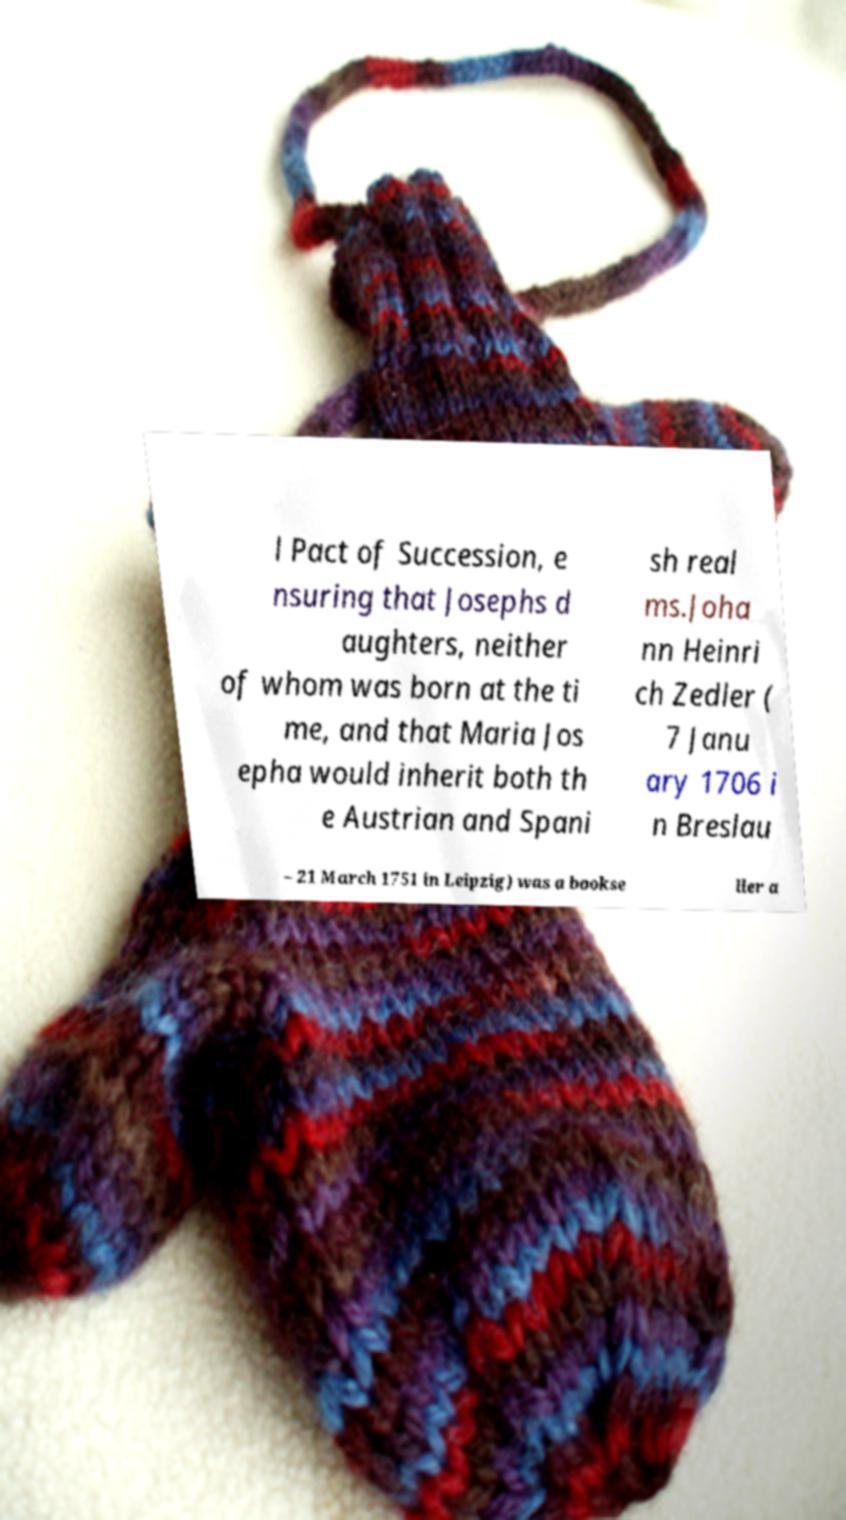There's text embedded in this image that I need extracted. Can you transcribe it verbatim? l Pact of Succession, e nsuring that Josephs d aughters, neither of whom was born at the ti me, and that Maria Jos epha would inherit both th e Austrian and Spani sh real ms.Joha nn Heinri ch Zedler ( 7 Janu ary 1706 i n Breslau – 21 March 1751 in Leipzig) was a bookse ller a 